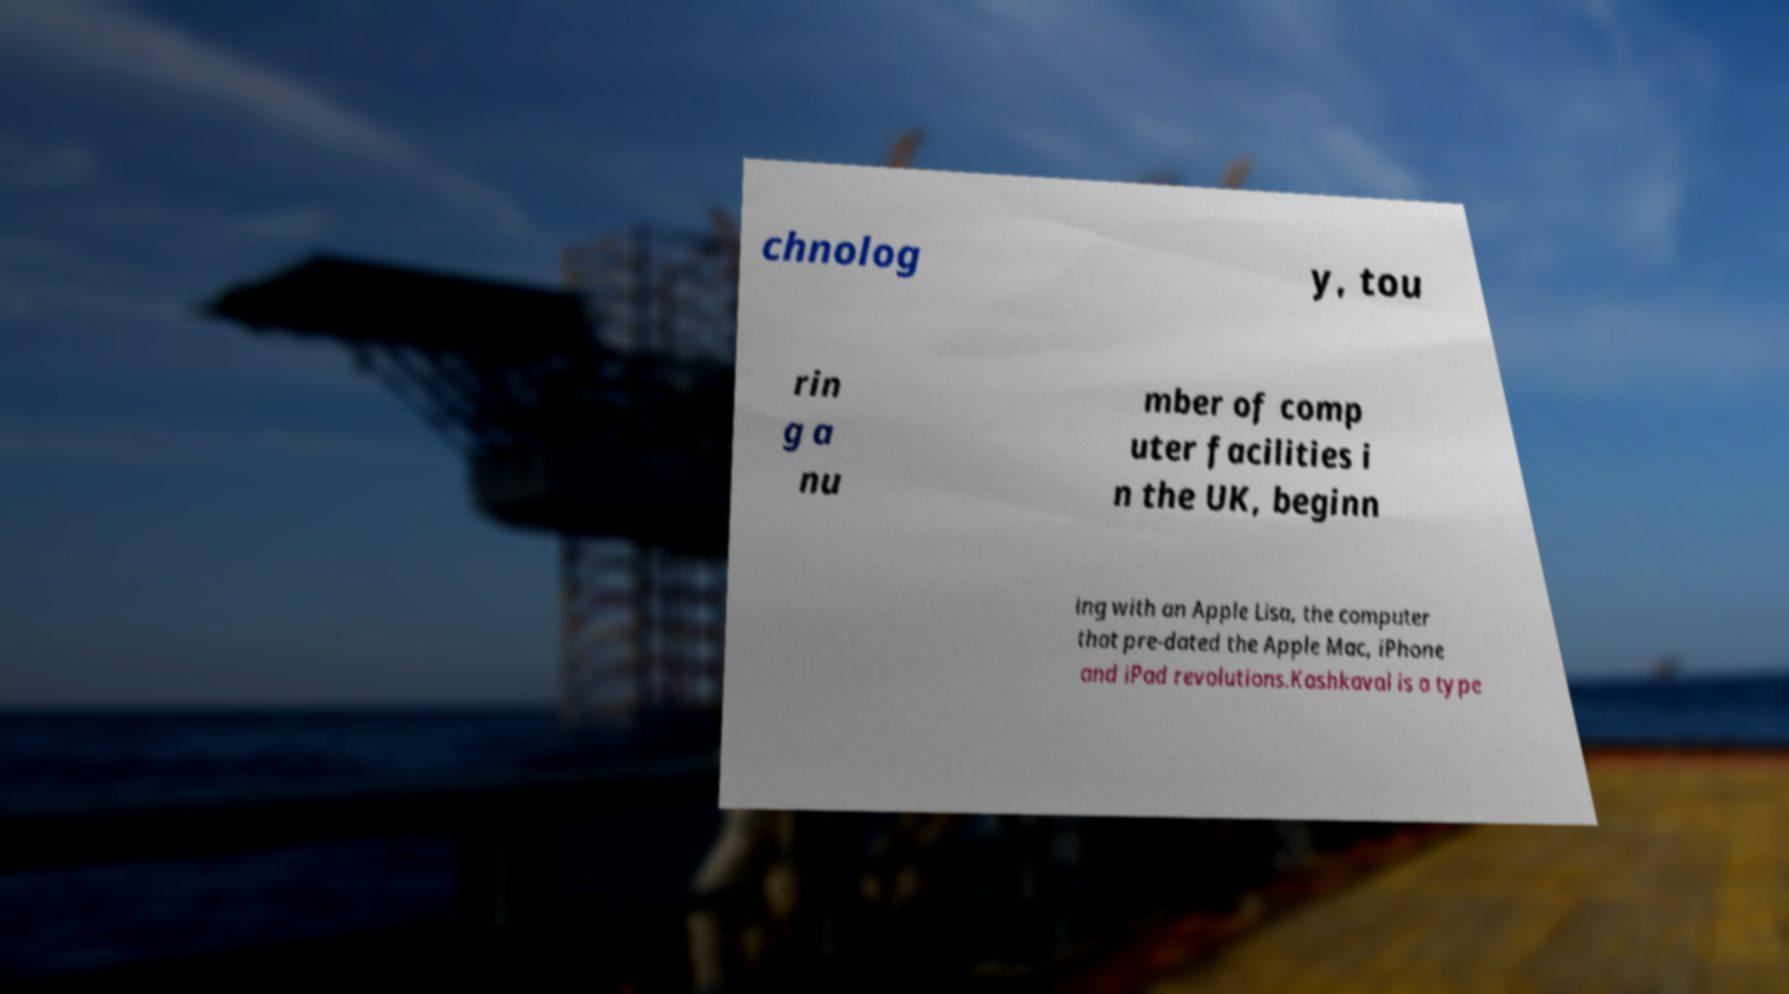I need the written content from this picture converted into text. Can you do that? chnolog y, tou rin g a nu mber of comp uter facilities i n the UK, beginn ing with an Apple Lisa, the computer that pre-dated the Apple Mac, iPhone and iPad revolutions.Kashkaval is a type 